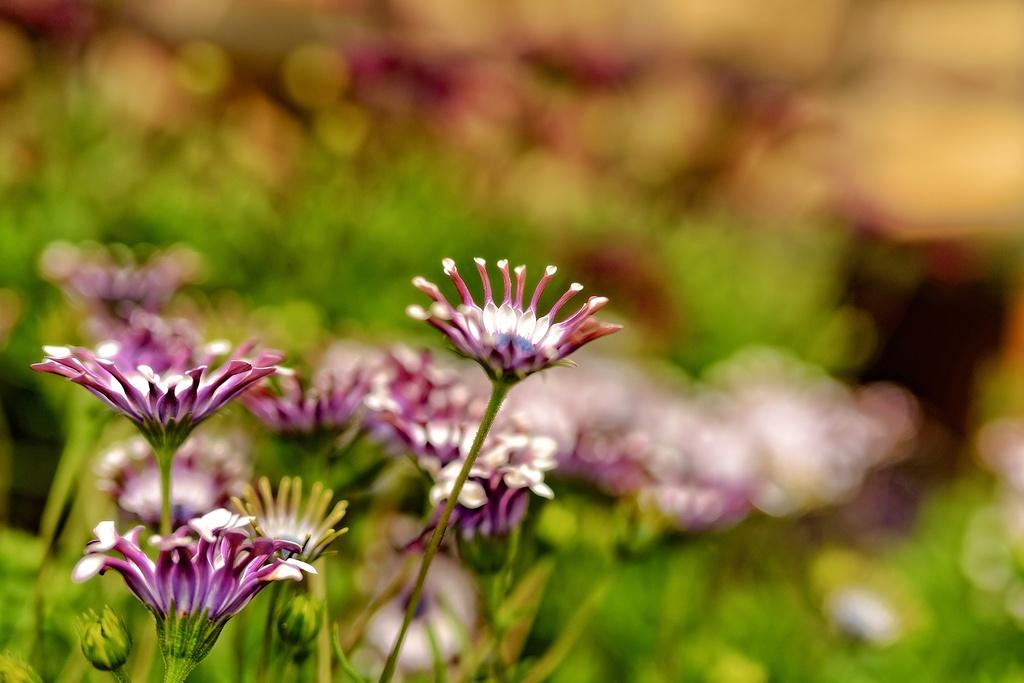What can be seen on the plants in the image? There are flowers on the plants in the image. What stage of growth can be observed on the plants in the image? There are buds on the plants in the image. How many cows can be seen grazing near the plants in the image? There are no cows present in the image; it only features plants with flowers and buds. What type of furniture is visible in the image? There is no furniture visible in the image. Is there a whistle being used by anyone in the image? There is no whistle present in the image. 